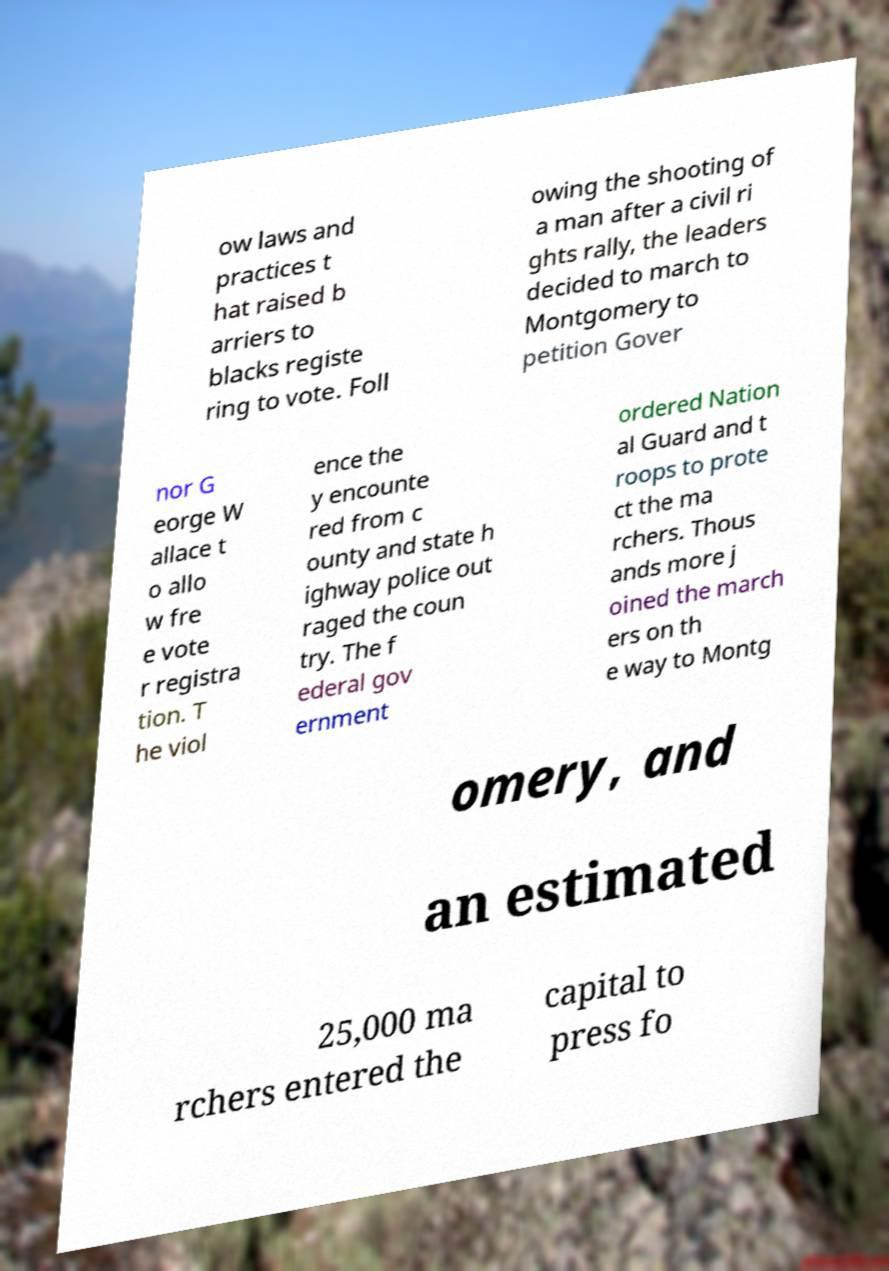Could you assist in decoding the text presented in this image and type it out clearly? ow laws and practices t hat raised b arriers to blacks registe ring to vote. Foll owing the shooting of a man after a civil ri ghts rally, the leaders decided to march to Montgomery to petition Gover nor G eorge W allace t o allo w fre e vote r registra tion. T he viol ence the y encounte red from c ounty and state h ighway police out raged the coun try. The f ederal gov ernment ordered Nation al Guard and t roops to prote ct the ma rchers. Thous ands more j oined the march ers on th e way to Montg omery, and an estimated 25,000 ma rchers entered the capital to press fo 